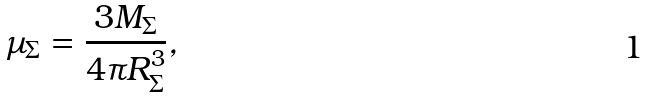<formula> <loc_0><loc_0><loc_500><loc_500>\mu _ { \Sigma } = \frac { 3 M _ { \Sigma } } { 4 \pi R _ { \Sigma } ^ { 3 } } ,</formula> 